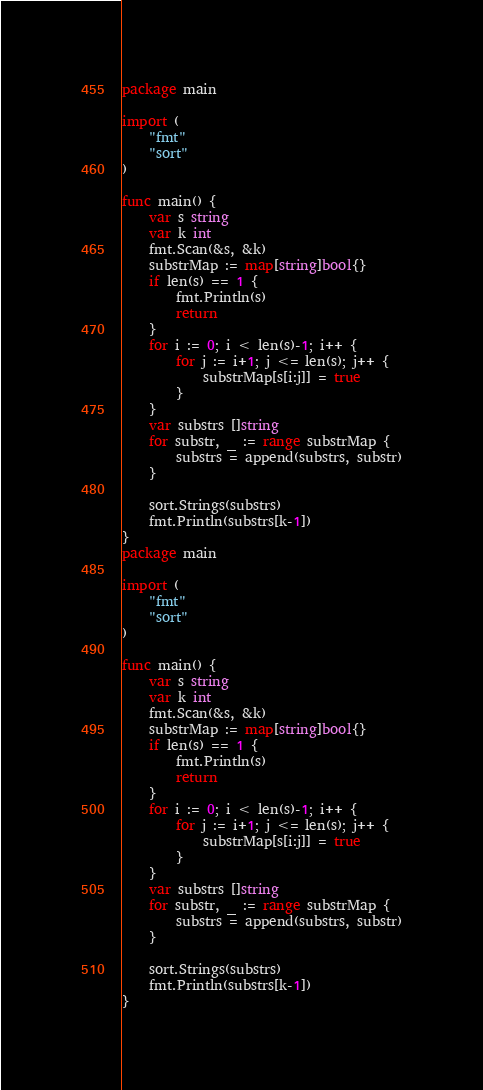Convert code to text. <code><loc_0><loc_0><loc_500><loc_500><_Go_>package main

import (
	"fmt"
	"sort"
)

func main() {
	var s string
	var k int
	fmt.Scan(&s, &k)
	substrMap := map[string]bool{}
	if len(s) == 1 {
		fmt.Println(s)
		return
	}
	for i := 0; i < len(s)-1; i++ {
		for j := i+1; j <= len(s); j++ {
			substrMap[s[i:j]] = true
		}
	}
	var substrs []string
	for substr, _ := range substrMap {
		substrs = append(substrs, substr)
	}

	sort.Strings(substrs)
	fmt.Println(substrs[k-1])
}
package main

import (
	"fmt"
	"sort"
)

func main() {
	var s string
	var k int
	fmt.Scan(&s, &k)
	substrMap := map[string]bool{}
	if len(s) == 1 {
		fmt.Println(s)
		return
	}
	for i := 0; i < len(s)-1; i++ {
		for j := i+1; j <= len(s); j++ {
			substrMap[s[i:j]] = true
		}
	}
	var substrs []string
	for substr, _ := range substrMap {
		substrs = append(substrs, substr)
	}

	sort.Strings(substrs)
	fmt.Println(substrs[k-1])
}
</code> 